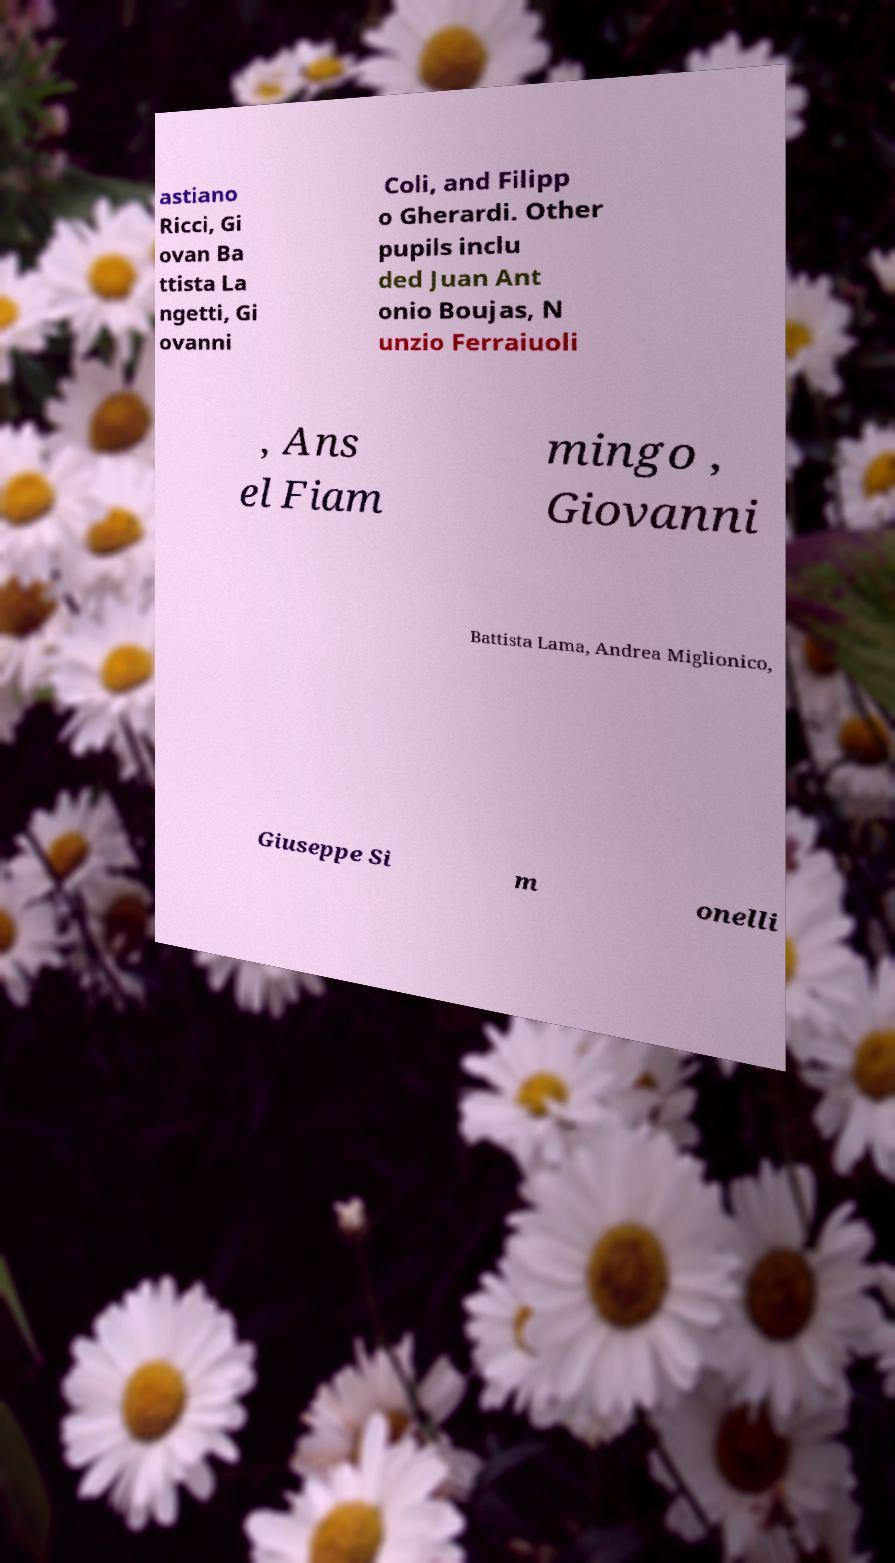Can you accurately transcribe the text from the provided image for me? astiano Ricci, Gi ovan Ba ttista La ngetti, Gi ovanni Coli, and Filipp o Gherardi. Other pupils inclu ded Juan Ant onio Boujas, N unzio Ferraiuoli , Ans el Fiam mingo , Giovanni Battista Lama, Andrea Miglionico, Giuseppe Si m onelli 